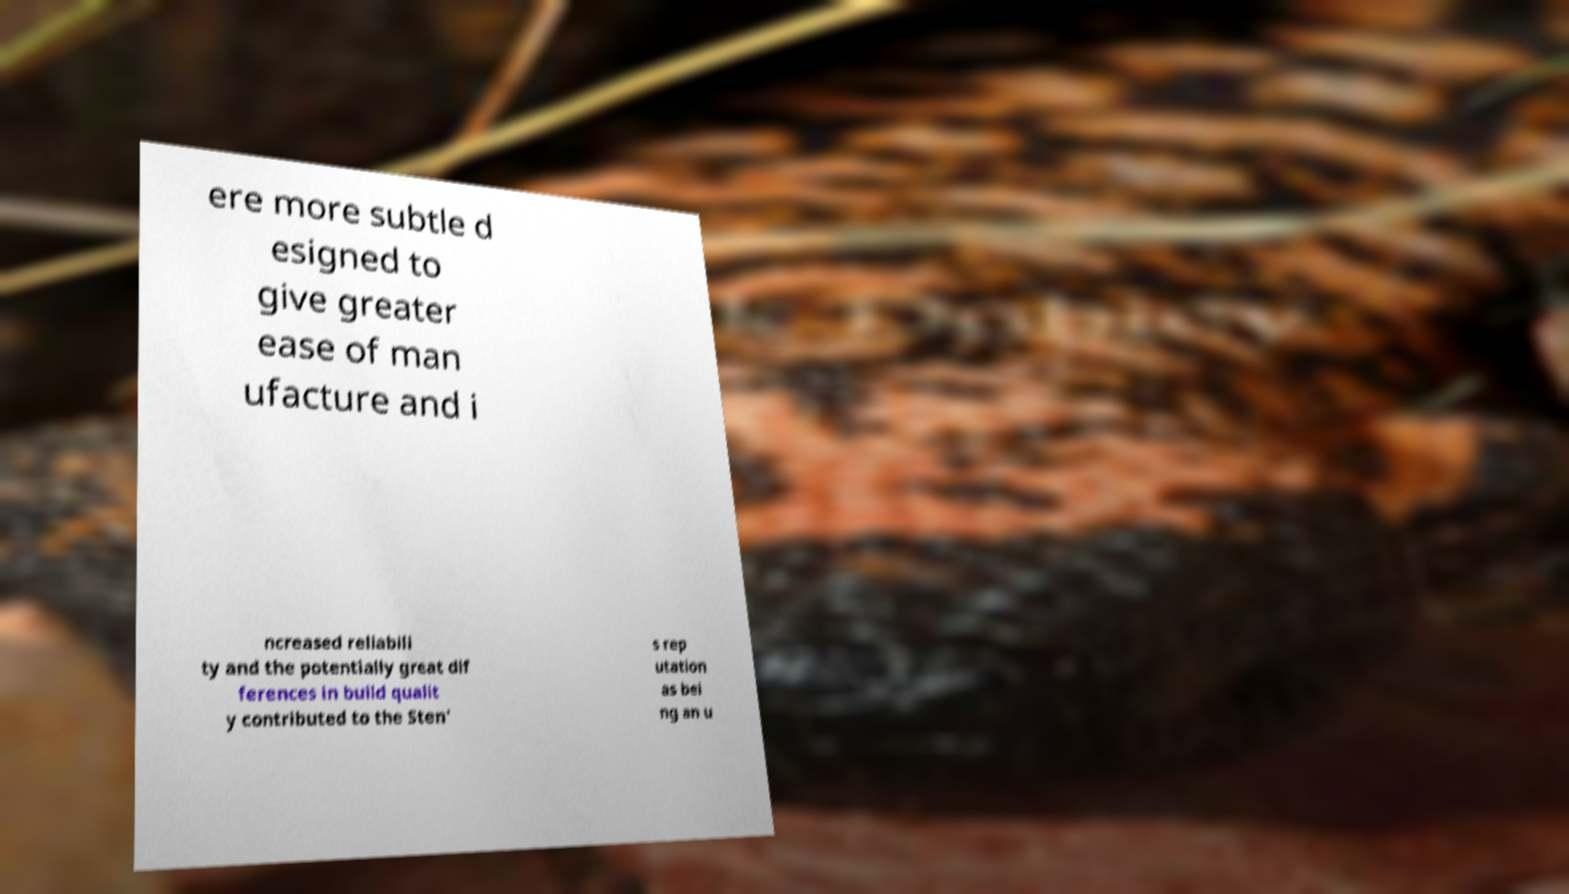For documentation purposes, I need the text within this image transcribed. Could you provide that? ere more subtle d esigned to give greater ease of man ufacture and i ncreased reliabili ty and the potentially great dif ferences in build qualit y contributed to the Sten' s rep utation as bei ng an u 